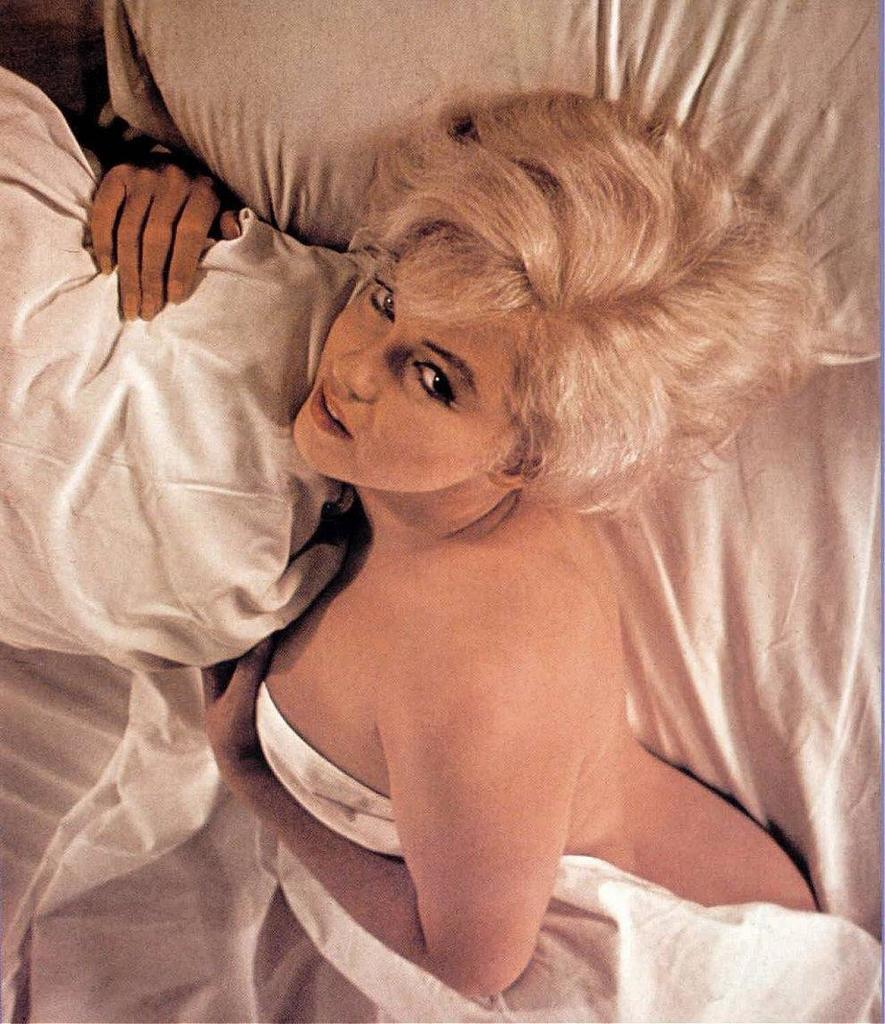Who is present in the image? There is a woman in the image. What is the woman doing in the image? The woman is laying on a bed. How many pillows are visible on the bed? There are two pillows visible on the bed. What type of juice is the woman drinking in the image? There is no juice present in the image; the woman is laying on a bed with two pillows. 